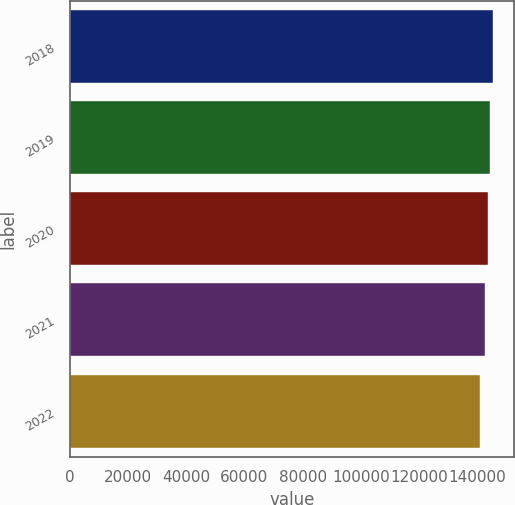<chart> <loc_0><loc_0><loc_500><loc_500><bar_chart><fcel>2018<fcel>2019<fcel>2020<fcel>2021<fcel>2022<nl><fcel>145300<fcel>144400<fcel>143600<fcel>142800<fcel>140900<nl></chart> 